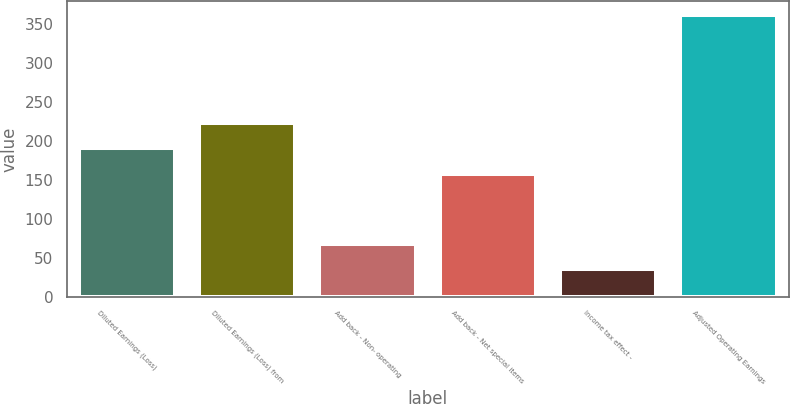<chart> <loc_0><loc_0><loc_500><loc_500><bar_chart><fcel>Diluted Earnings (Loss)<fcel>Diluted Earnings (Loss) from<fcel>Add back - Non- operating<fcel>Add back - Net special items<fcel>Income tax effect -<fcel>Adjusted Operating Earnings<nl><fcel>190.6<fcel>223.2<fcel>67.6<fcel>158<fcel>35<fcel>361<nl></chart> 